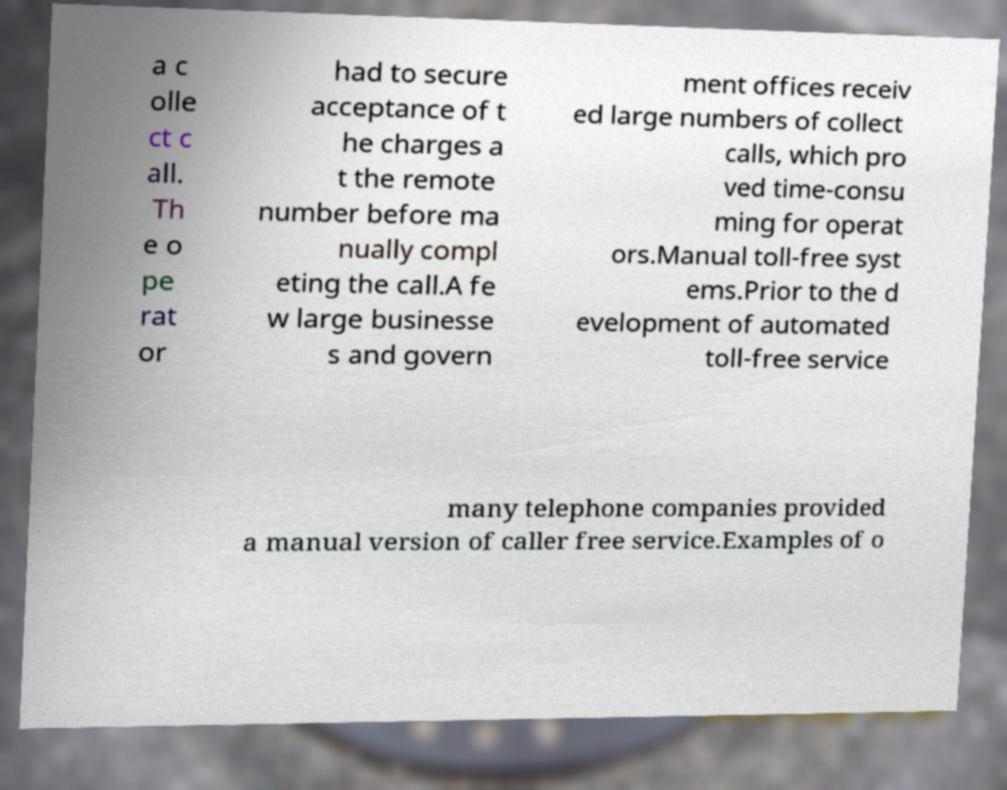Please read and relay the text visible in this image. What does it say? a c olle ct c all. Th e o pe rat or had to secure acceptance of t he charges a t the remote number before ma nually compl eting the call.A fe w large businesse s and govern ment offices receiv ed large numbers of collect calls, which pro ved time-consu ming for operat ors.Manual toll-free syst ems.Prior to the d evelopment of automated toll-free service many telephone companies provided a manual version of caller free service.Examples of o 